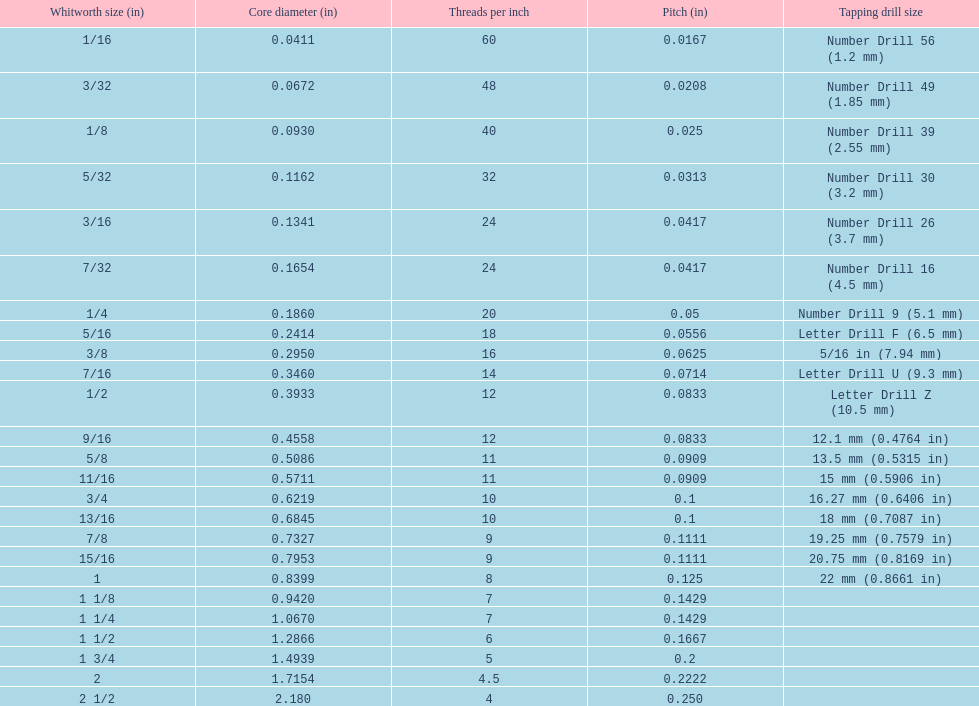What is the primary diameter of the first 1/8 whitworth dimension (in)? 0.0930. 